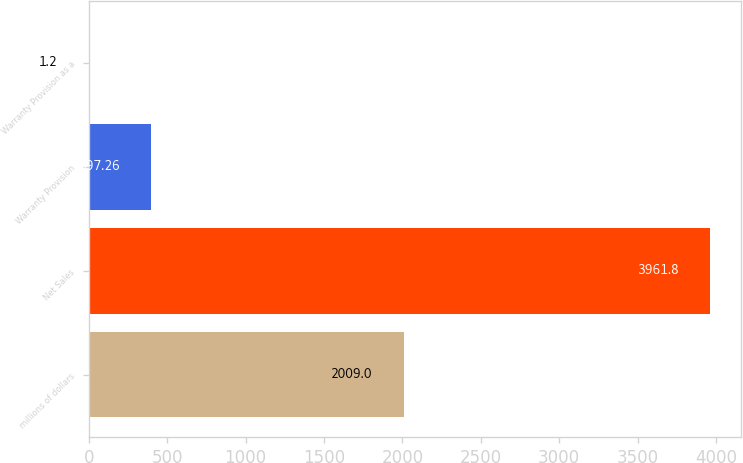<chart> <loc_0><loc_0><loc_500><loc_500><bar_chart><fcel>millions of dollars<fcel>Net Sales<fcel>Warranty Provision<fcel>Warranty Provision as a<nl><fcel>2009<fcel>3961.8<fcel>397.26<fcel>1.2<nl></chart> 